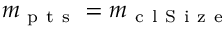Convert formula to latex. <formula><loc_0><loc_0><loc_500><loc_500>m _ { p t s } = m _ { c l S i z e }</formula> 